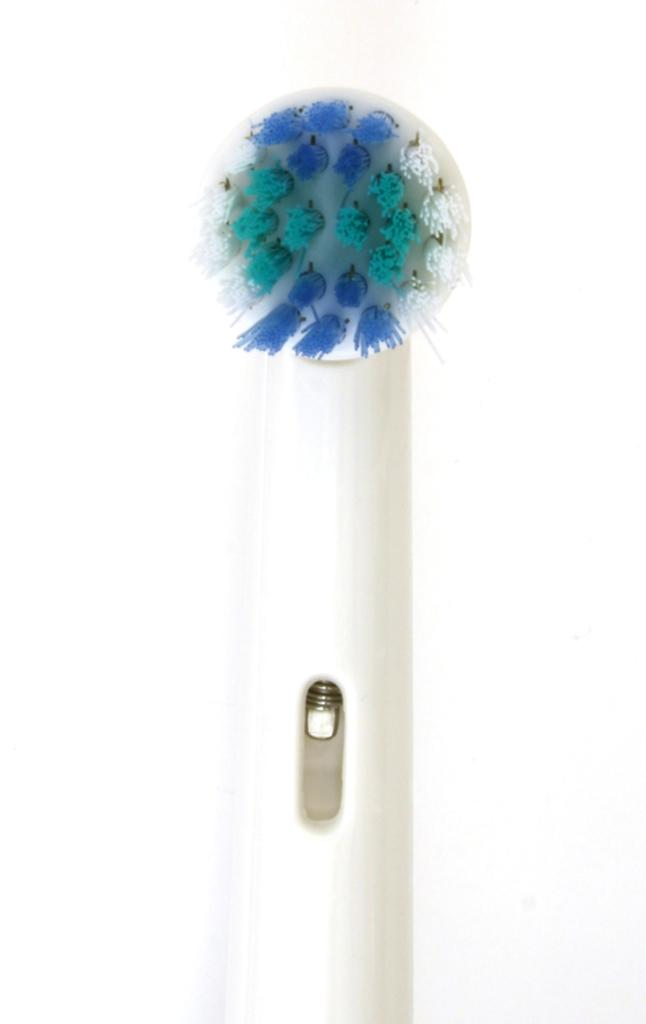What object can be seen in the image? There is a brush in the image. What color is the background of the image? The background of the image is white. What type of wealth is depicted in the image? There is no depiction of wealth in the image; it only features a brush and a white background. 